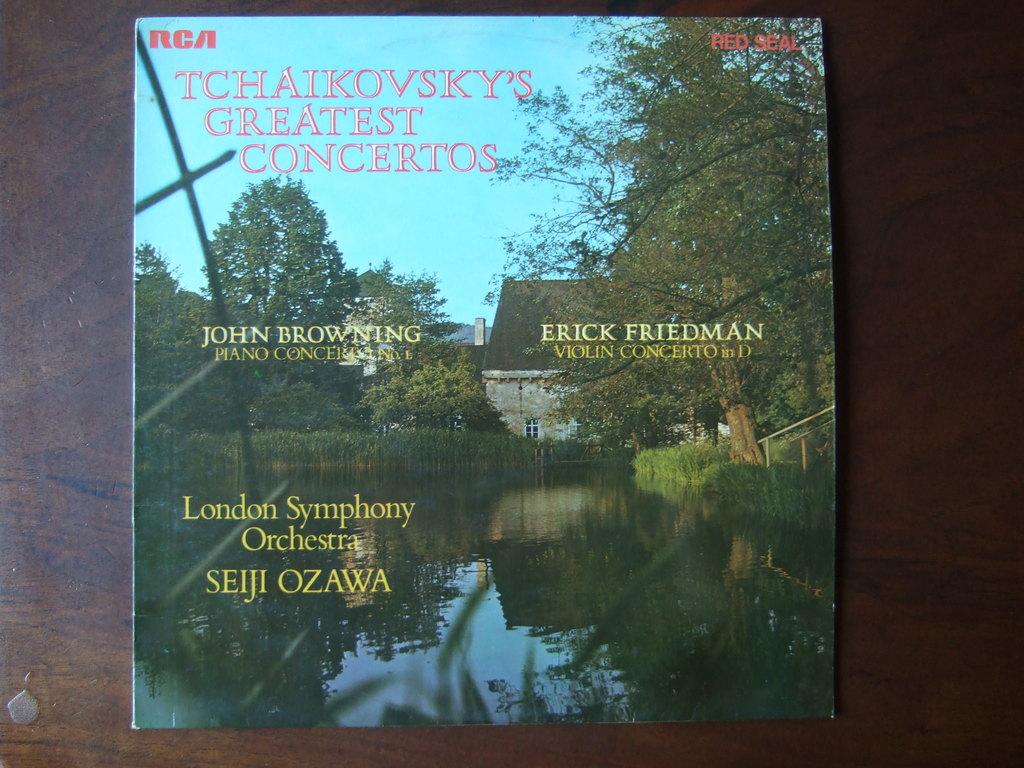Where is the picture taken?
Your answer should be very brief. Unanswerable. What is teh brand at the top left corner?
Your answer should be compact. Rca. 